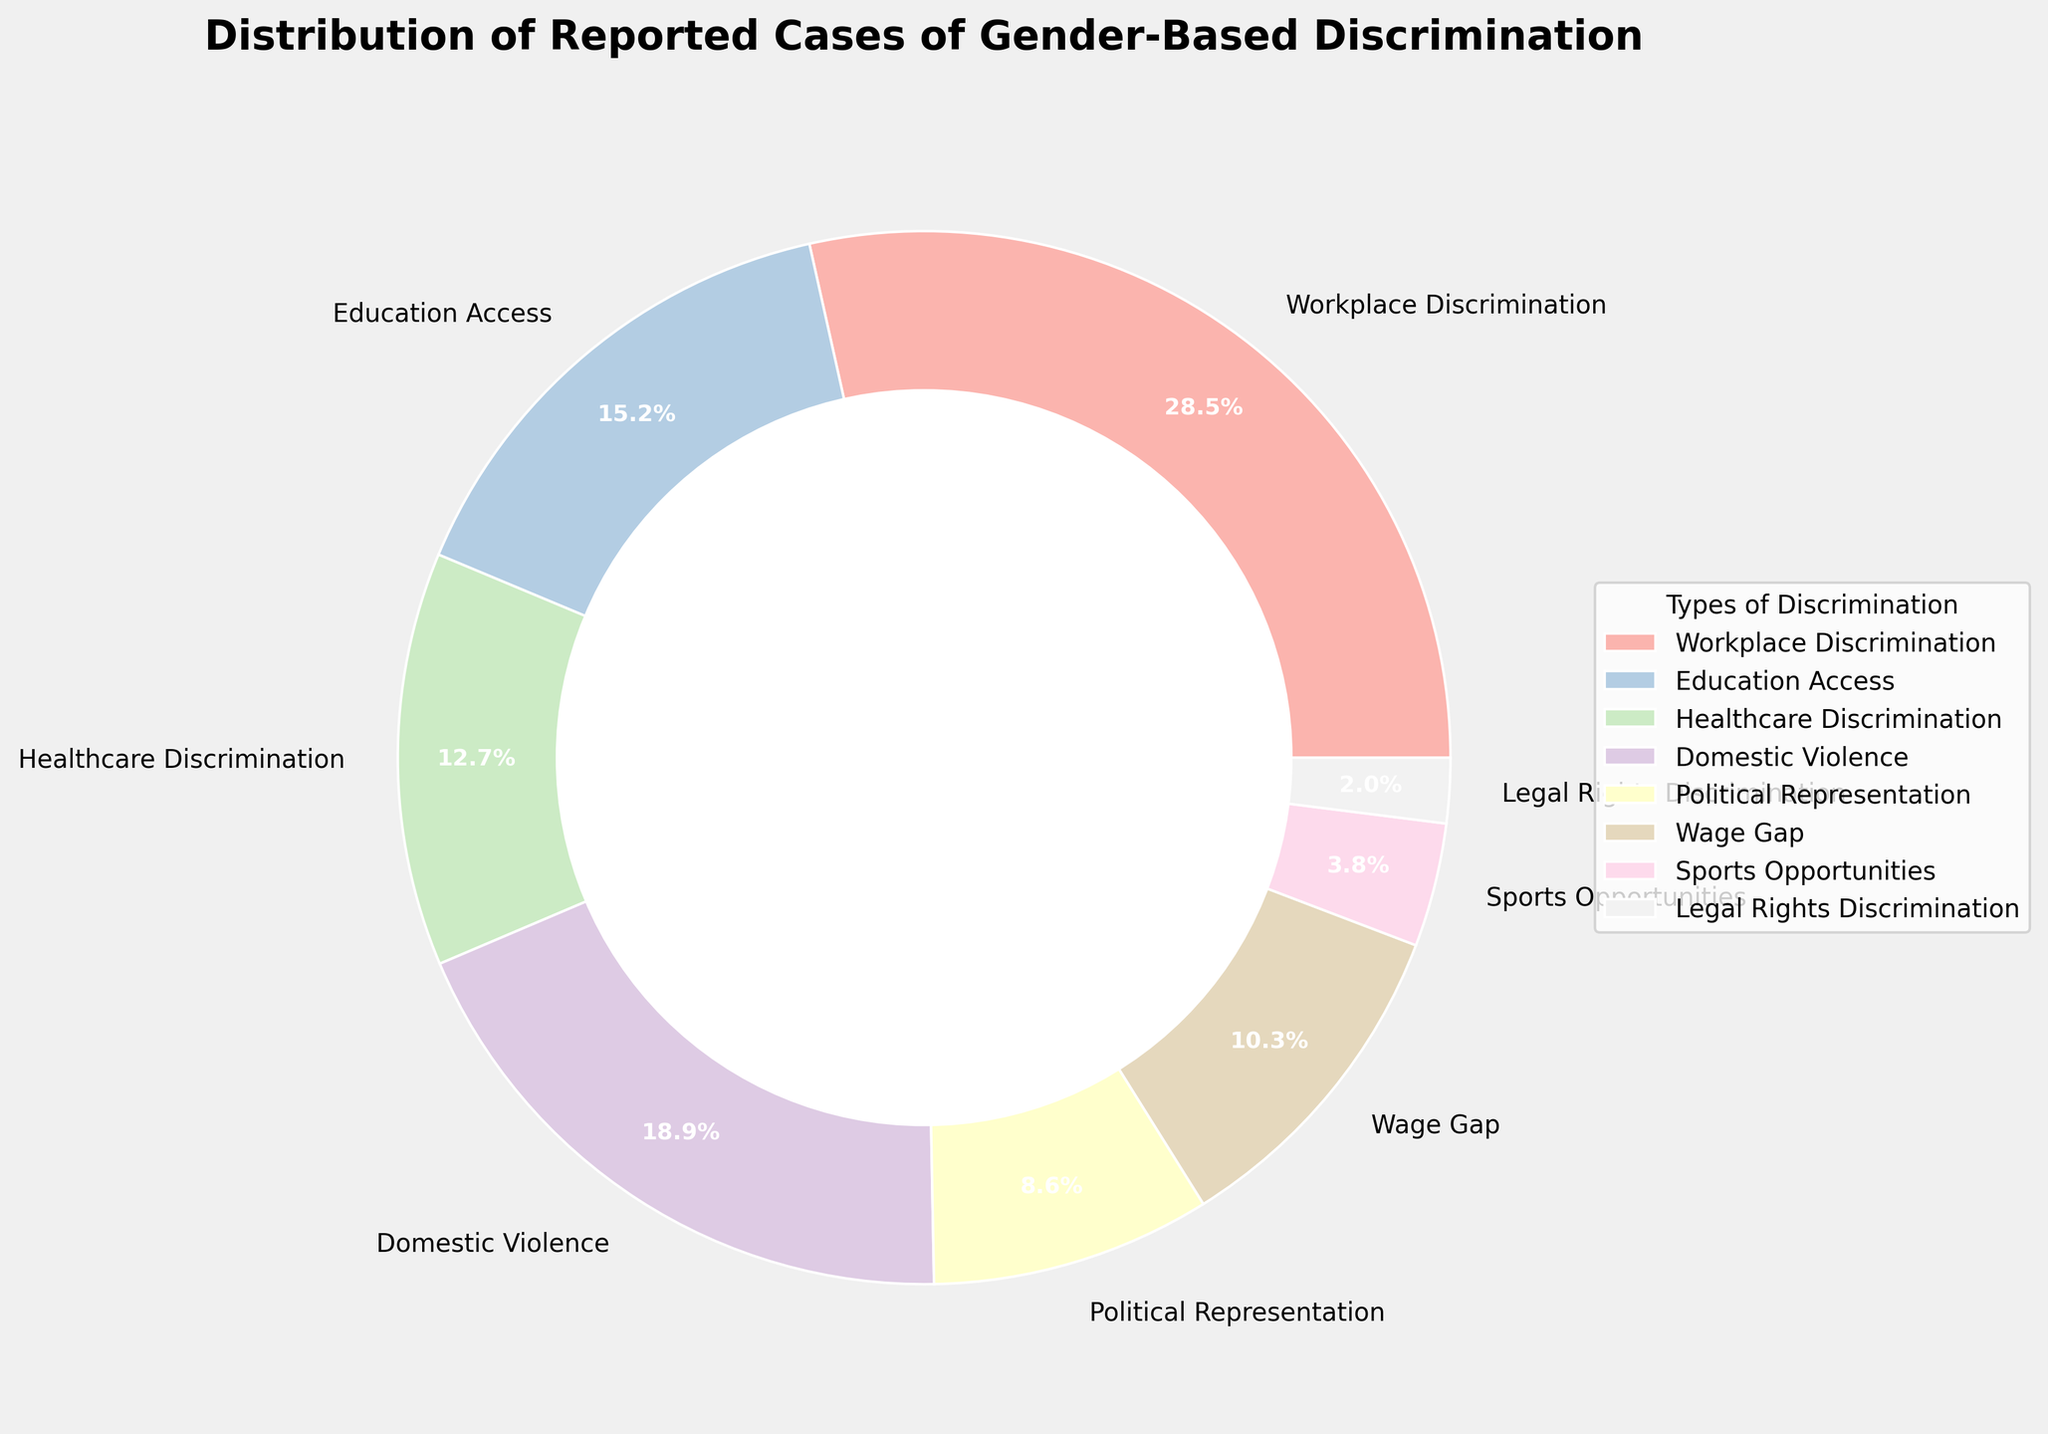Which type of discrimination has the smallest percentage in the reported cases? By examining the pie chart and looking for the smallest segment, we see that "Legal Rights Discrimination" has the smallest percentage at 2.0%.
Answer: Legal Rights Discrimination Which two types of discrimination together account for the largest percentage of reported cases? The segments "Workplace Discrimination" (28.5%) and "Domestic Violence" (18.9%) are the largest. Adding their percentages gives 28.5 + 18.9 = 47.4%. These two types together account for the largest percentage.
Answer: Workplace Discrimination and Domestic Violence Compare the reported cases of "Healthcare Discrimination" and "Sports Opportunities." Which one has a higher percentage and by how much? The pie chart shows "Healthcare Discrimination" at 12.7% and "Sports Opportunities" at 3.8%. The difference is 12.7 - 3.8 = 8.9%. "Healthcare Discrimination" has a higher percentage by 8.9%.
Answer: Healthcare Discrimination by 8.9% What color represents "Education Access" in the pie chart? By identifying the label "Education Access" on the pie chart and tracing its corresponding color segment, we see it is represented by a light pink color.
Answer: Light pink Calculate the total percentage for "Workplace Discrimination," "Education Access," and "Healthcare Discrimination." Adding the percentages for these three types: 28.5% (Workplace Discrimination) + 15.2% (Education Access) + 12.7% (Healthcare Discrimination) = 56.4%.
Answer: 56.4% Between "Wage Gap" and "Political Representation," which has the higher percentage of reported cases? By comparing the segments, "Wage Gap" is at 10.3% while "Political Representation" is at 8.6%. "Wage Gap" has a higher percentage.
Answer: Wage Gap How much more reported cases does "Domestic Violence" have compared to "Sports Opportunities"? "Domestic Violence" is at 18.9% and "Sports Opportunities" is at 3.8%. The difference is 18.9 - 3.8 = 15.1%.
Answer: 15.1% What percentage of reported cases is related to types of discrimination other than "Workplace Discrimination" and "Domestic Violence"? Adding up the percentages for all types except "Workplace Discrimination" (28.5%) and "Domestic Violence" (18.9%): 15.2 (Education Access) + 12.7 (Healthcare Discrimination) + 8.6 (Political Representation) + 10.3 (Wage Gap) + 3.8 (Sports Opportunities) + 2.0 (Legal Rights Discrimination) = 52.6%.
Answer: 52.6% 